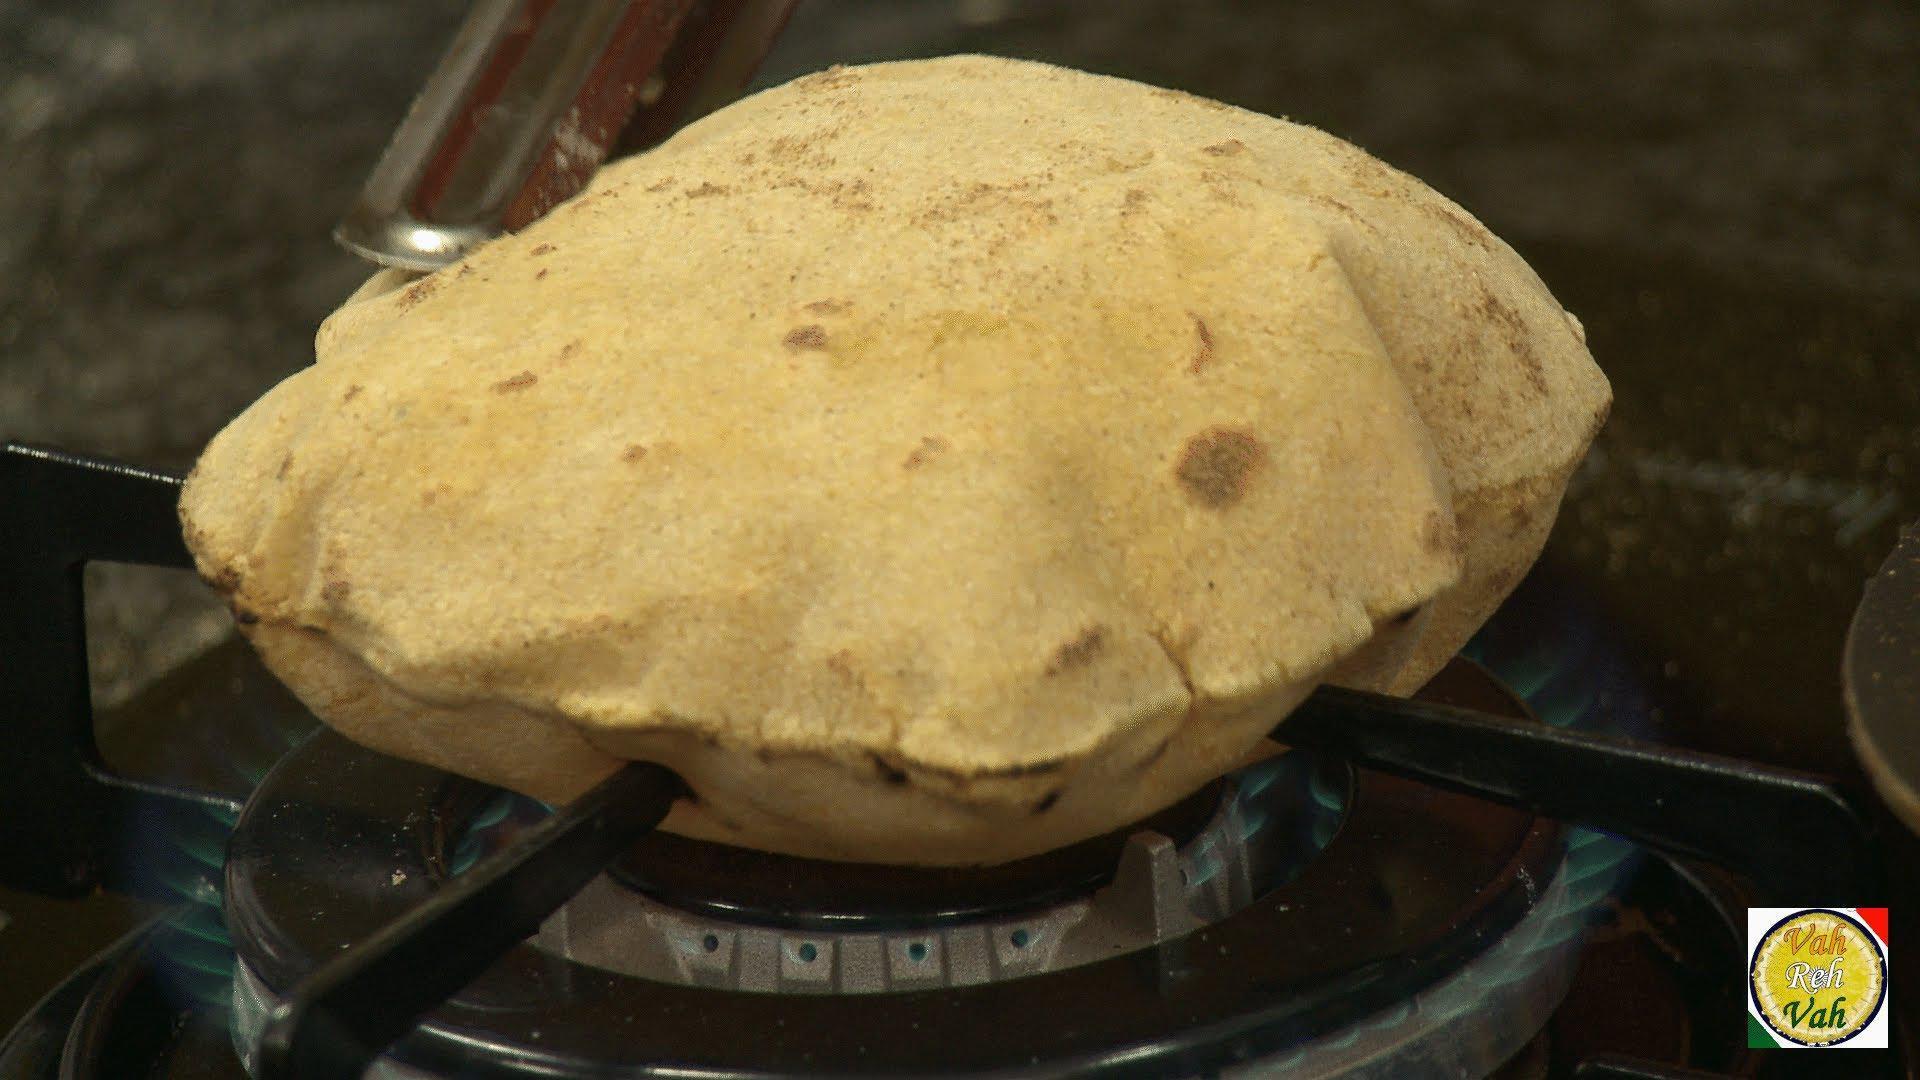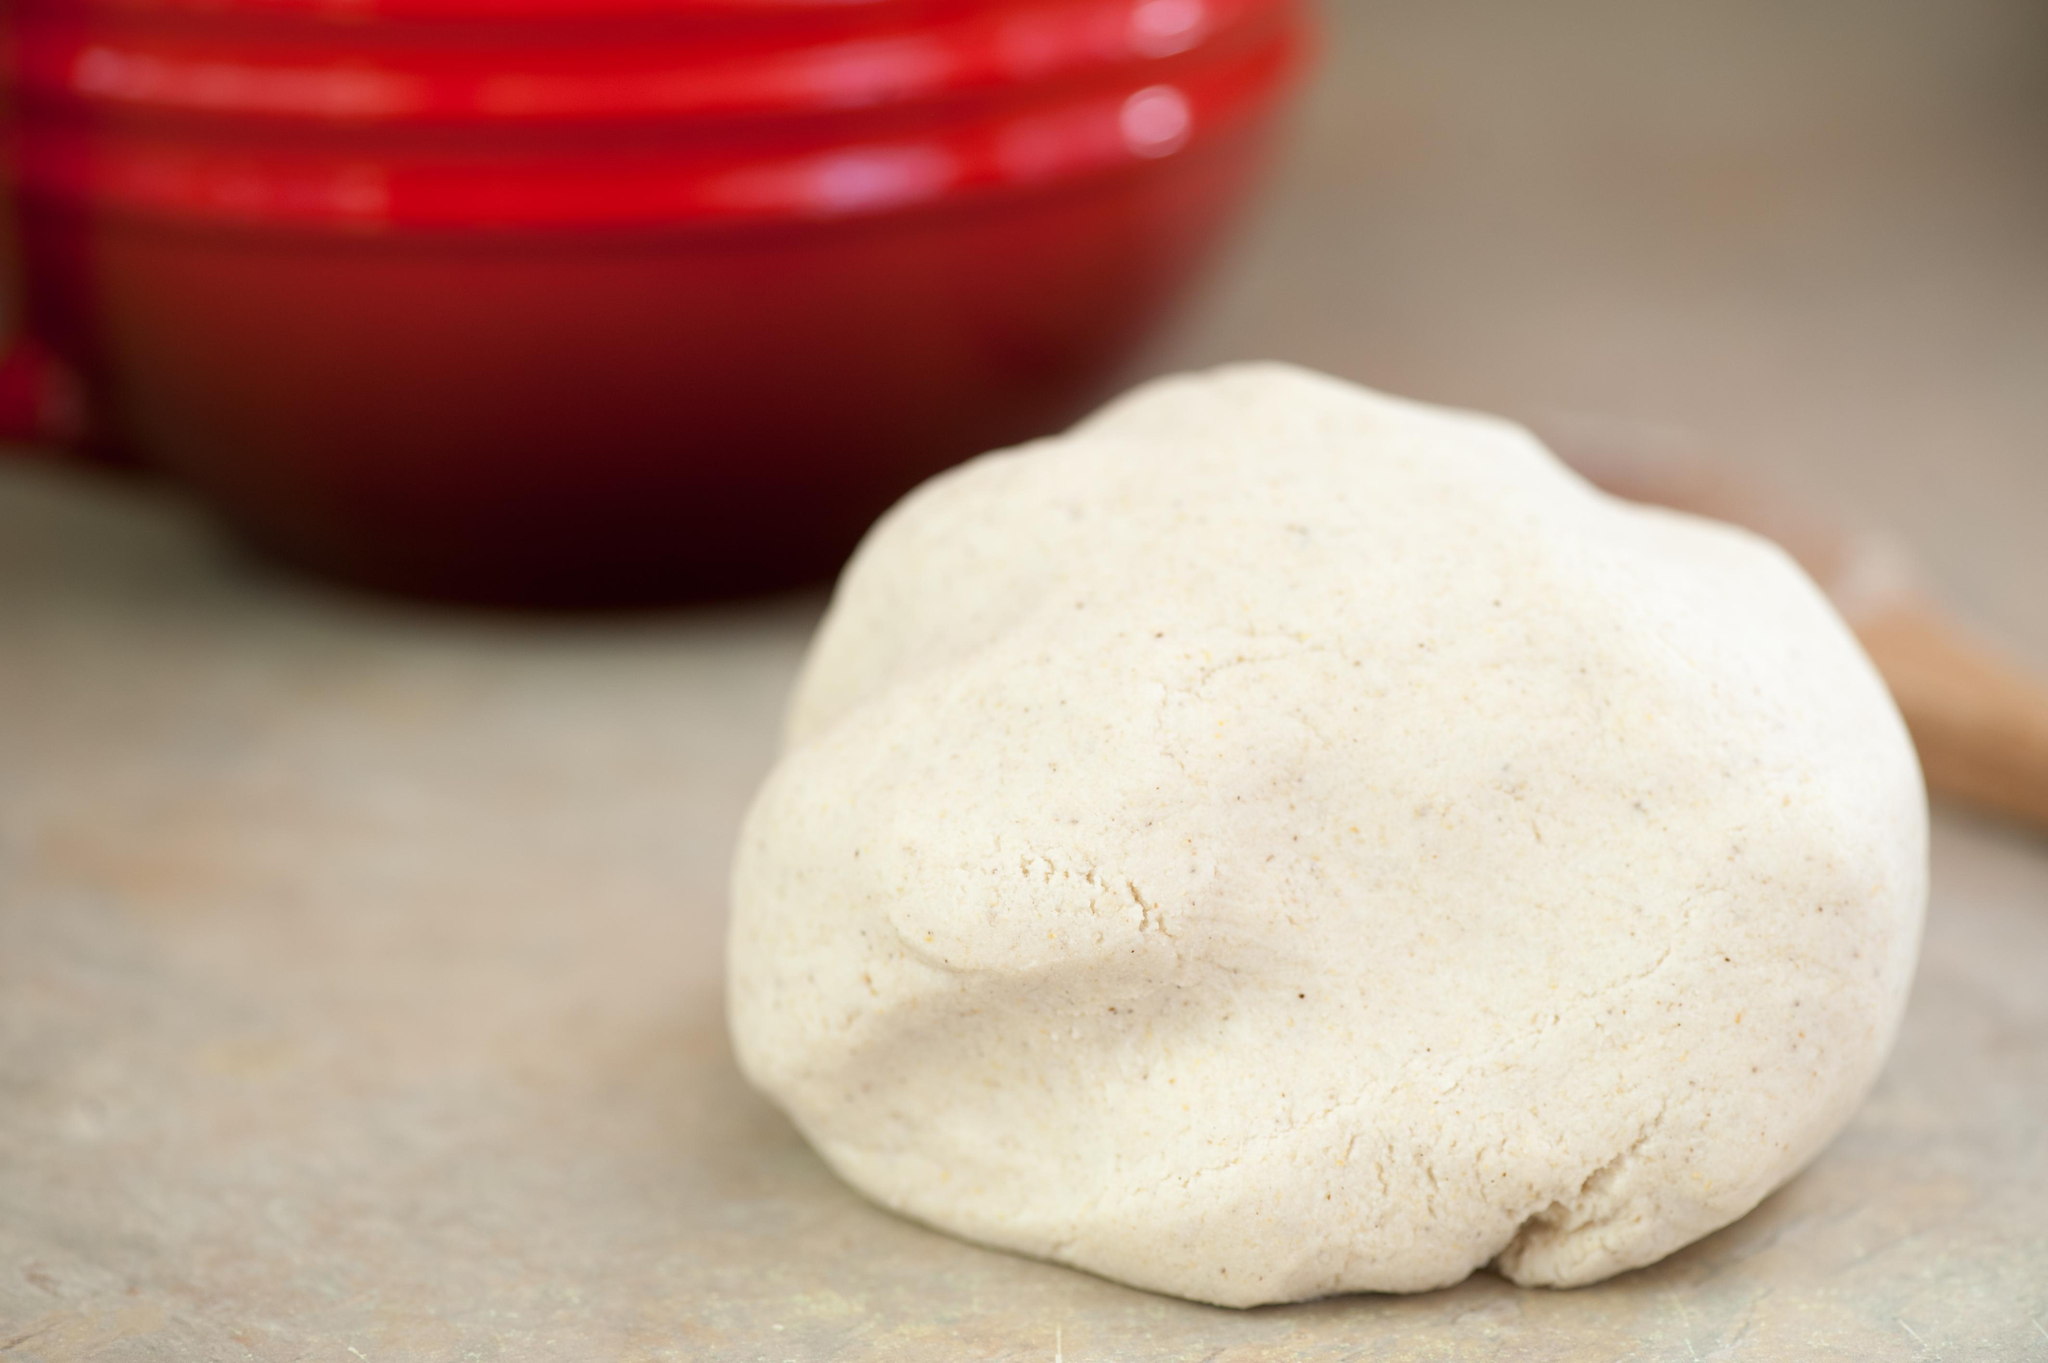The first image is the image on the left, the second image is the image on the right. Given the left and right images, does the statement "In at least one image there is a single loaf of bread being made on a single heat source." hold true? Answer yes or no. Yes. The first image is the image on the left, the second image is the image on the right. For the images shown, is this caption "One image features one rounded raw dough ball sitting on a flat surface but not in a container." true? Answer yes or no. Yes. 